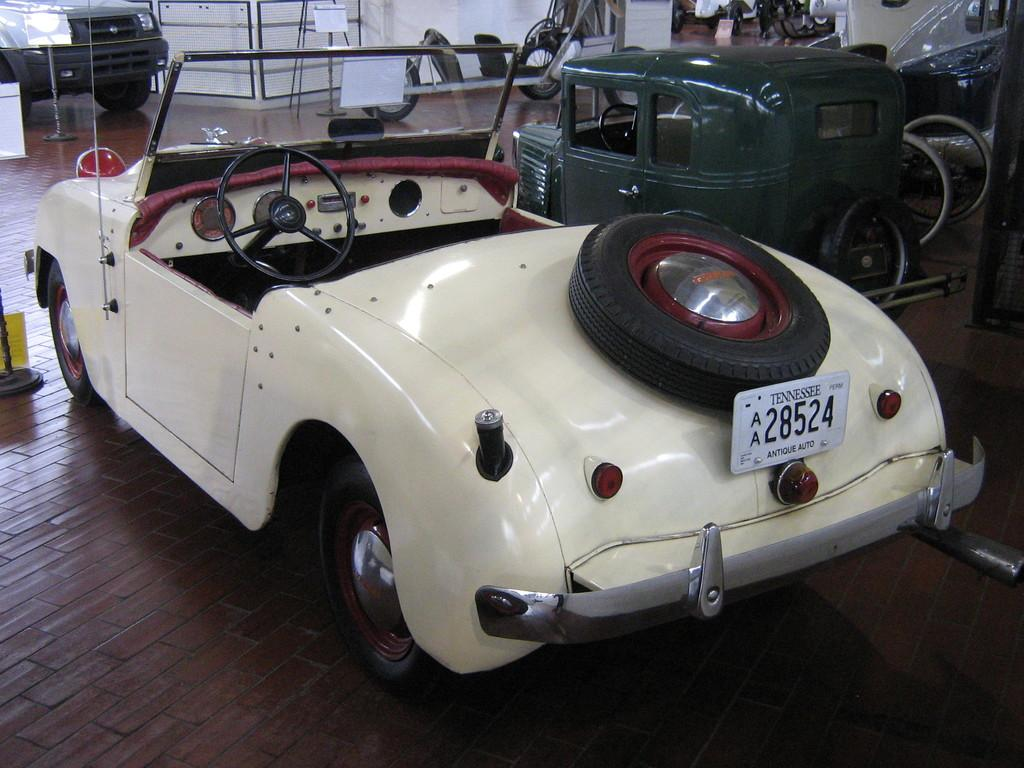What types of vehicles can be seen in the image? There are vehicles in the image, including a car. Can you describe the car in the image? The car has a tire and a number plate. What is visible in the background of the image? There is a wall in the background of the image. What type of structure is present in the image? There are railings in the image. How many quince are being used to wash the car in the image? There are no quince present in the image, and the car is not being washed. Can you describe the jump that the soap is performing in the image? There is no soap or jumping action depicted in the image. 